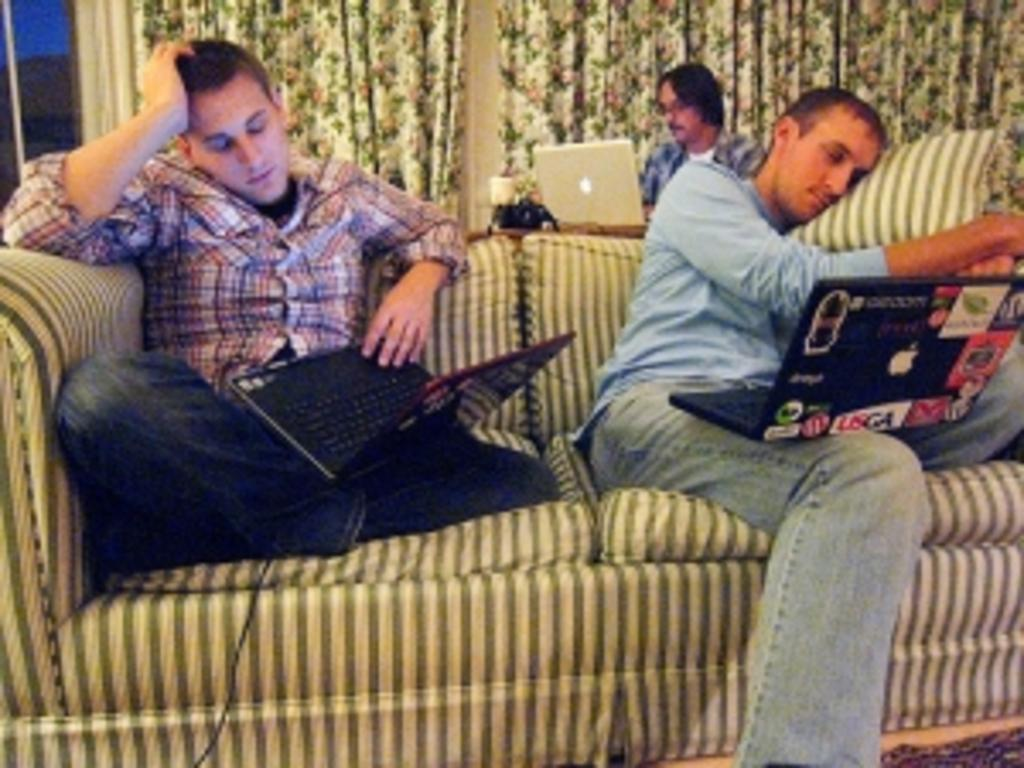How many people are sitting on the sofa in the image? There are 2 people sitting on the sofa in the image. What are the people on the sofa doing? Each person is holding a laptop. Can you describe the person sitting behind them? The person behind them is sitting and operating a laptop. What can be seen in the background of the image? There are curtains visible in the image. What type of apple can be seen on the feet of the person sitting on the sofa? There is no apple present in the image, and no mention of feet or any object on them. 